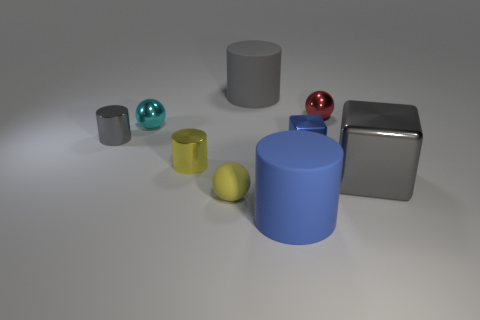Is the number of big shiny objects in front of the large blue cylinder less than the number of yellow metal cylinders behind the gray cube?
Provide a short and direct response. Yes. The large matte object in front of the gray shiny thing that is to the left of the small yellow sphere is what shape?
Keep it short and to the point. Cylinder. Is there a large yellow shiny block?
Keep it short and to the point. No. What is the color of the matte cylinder in front of the red ball?
Provide a succinct answer. Blue. There is a small cylinder that is the same color as the big shiny object; what material is it?
Give a very brief answer. Metal. There is a tiny red object; are there any small spheres left of it?
Give a very brief answer. Yes. Are there more tiny gray objects than blue matte cubes?
Provide a short and direct response. Yes. What color is the large rubber thing that is on the left side of the big cylinder that is on the right side of the large matte thing that is behind the small yellow metallic object?
Offer a terse response. Gray. There is a big cube that is the same material as the tiny red sphere; what color is it?
Give a very brief answer. Gray. What number of things are objects on the right side of the small yellow cylinder or small spheres on the right side of the tiny metal cube?
Offer a terse response. 6. 